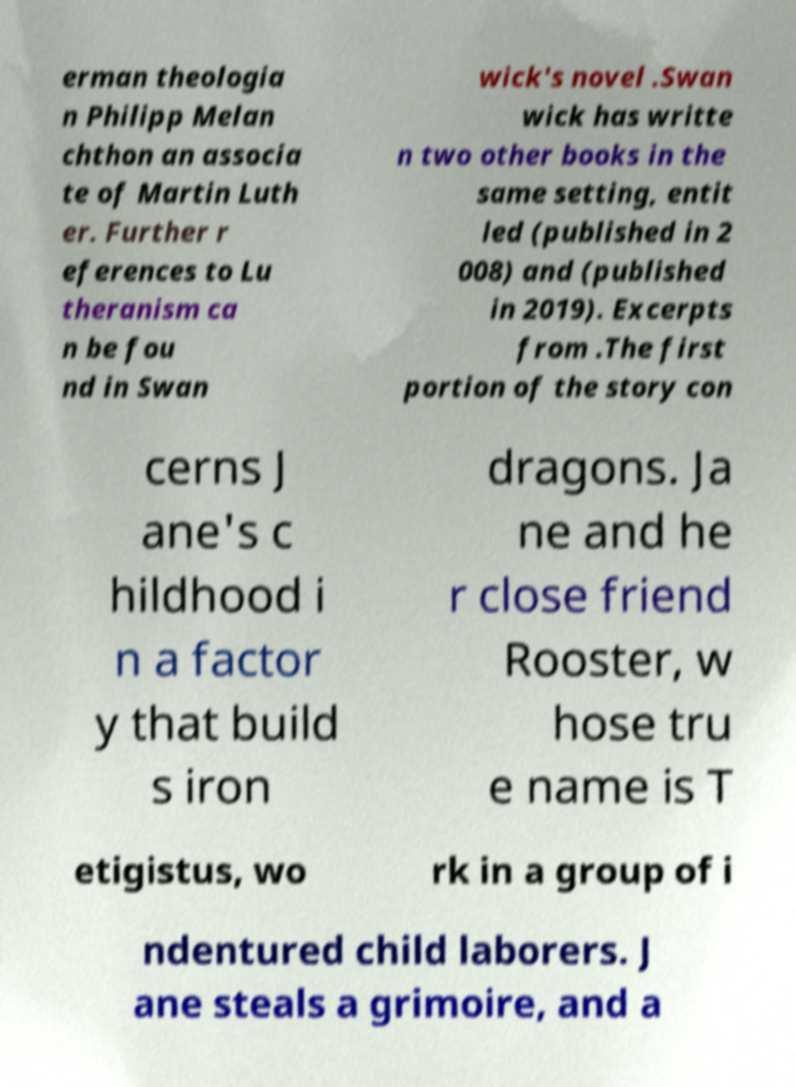Please read and relay the text visible in this image. What does it say? erman theologia n Philipp Melan chthon an associa te of Martin Luth er. Further r eferences to Lu theranism ca n be fou nd in Swan wick's novel .Swan wick has writte n two other books in the same setting, entit led (published in 2 008) and (published in 2019). Excerpts from .The first portion of the story con cerns J ane's c hildhood i n a factor y that build s iron dragons. Ja ne and he r close friend Rooster, w hose tru e name is T etigistus, wo rk in a group of i ndentured child laborers. J ane steals a grimoire, and a 